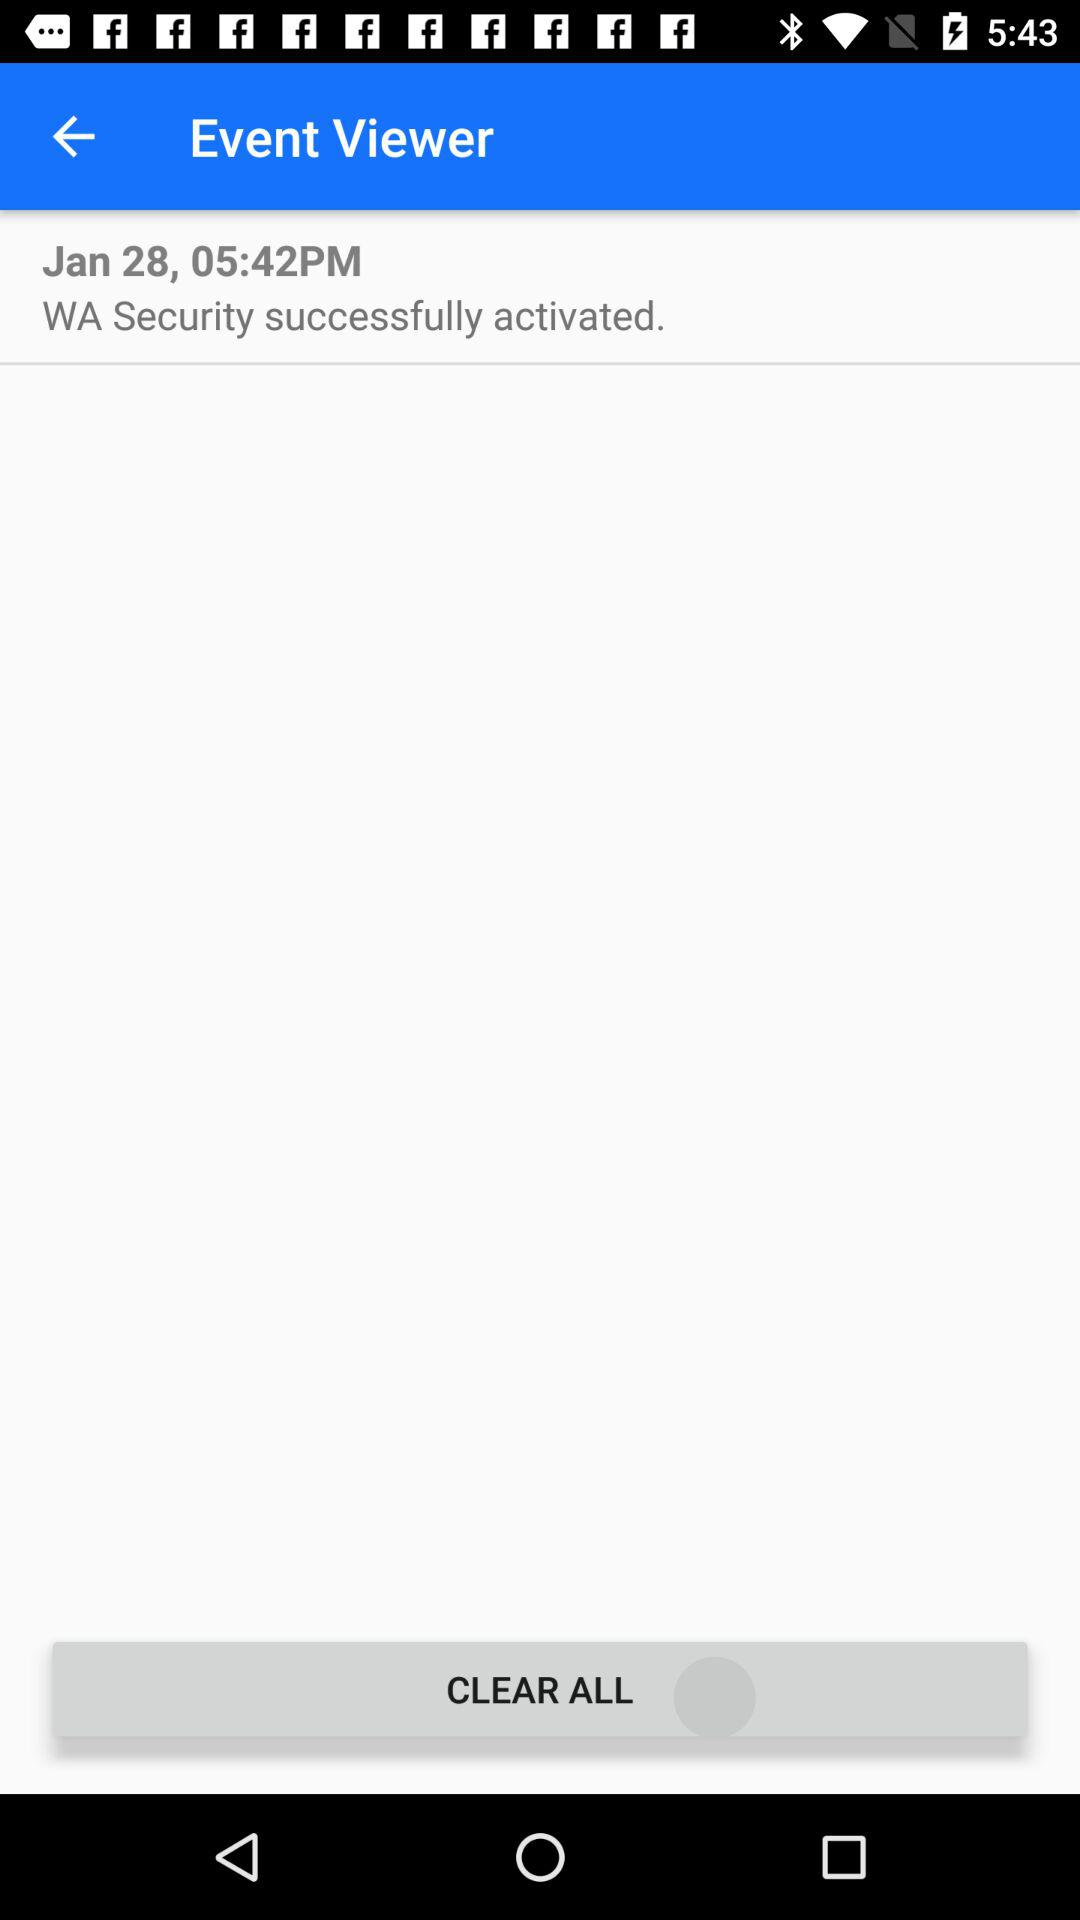What is the mentioned time? The mentioned time is 05:42 PM. 